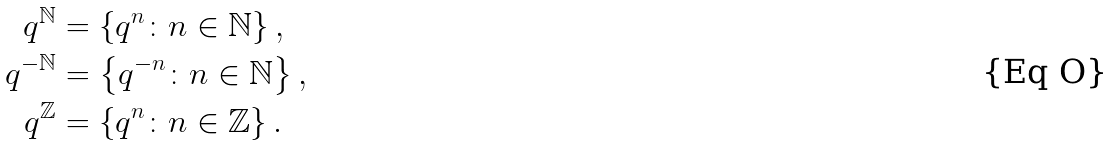Convert formula to latex. <formula><loc_0><loc_0><loc_500><loc_500>q ^ { \mathbb { N } } & = \left \{ q ^ { n } \colon n \in \mathbb { N } \right \} , \\ q ^ { - \mathbb { N } } & = \left \{ q ^ { - n } \colon n \in \mathbb { N } \right \} , \\ q ^ { \mathbb { Z } } & = \left \{ q ^ { n } \colon n \in \mathbb { Z } \right \} .</formula> 